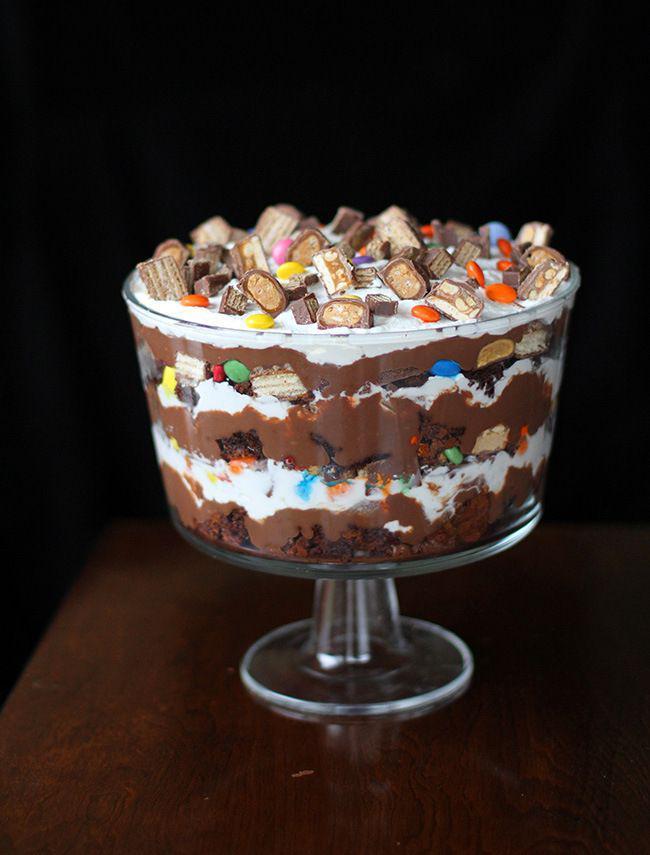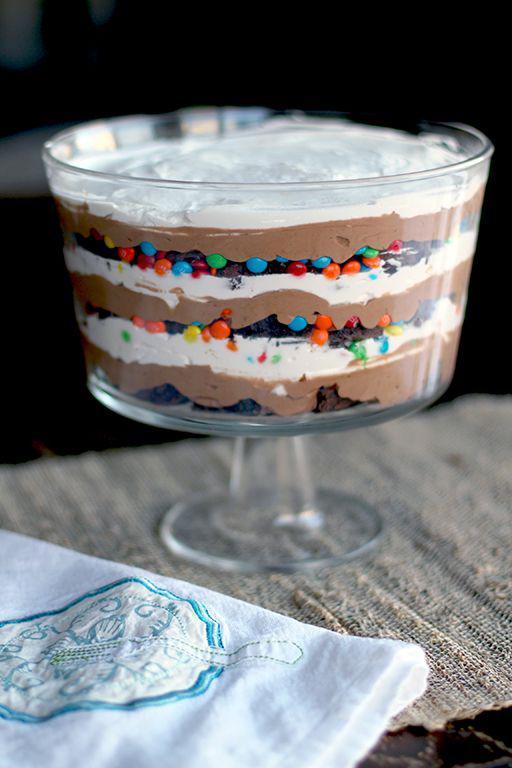The first image is the image on the left, the second image is the image on the right. Examine the images to the left and right. Is the description "One of the images features three trifle desserts served individually." accurate? Answer yes or no. No. 